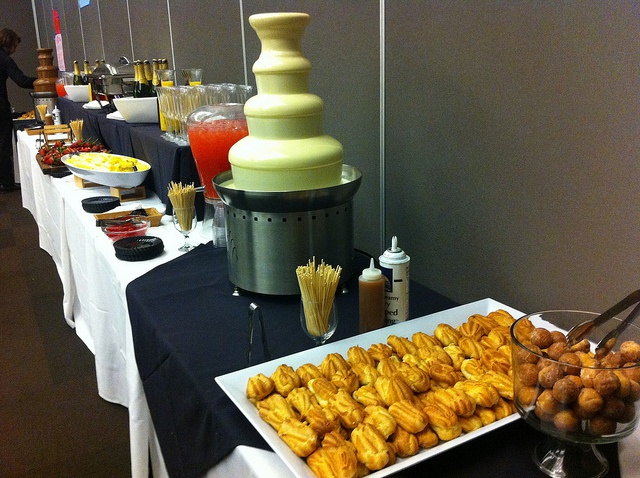Describe the objects in this image and their specific colors. I can see dining table in black, white, olive, and orange tones, bowl in black, brown, and maroon tones, bowl in black, ivory, darkgray, yellow, and khaki tones, bottle in black, maroon, lightblue, and beige tones, and wine glass in black, olive, and gray tones in this image. 